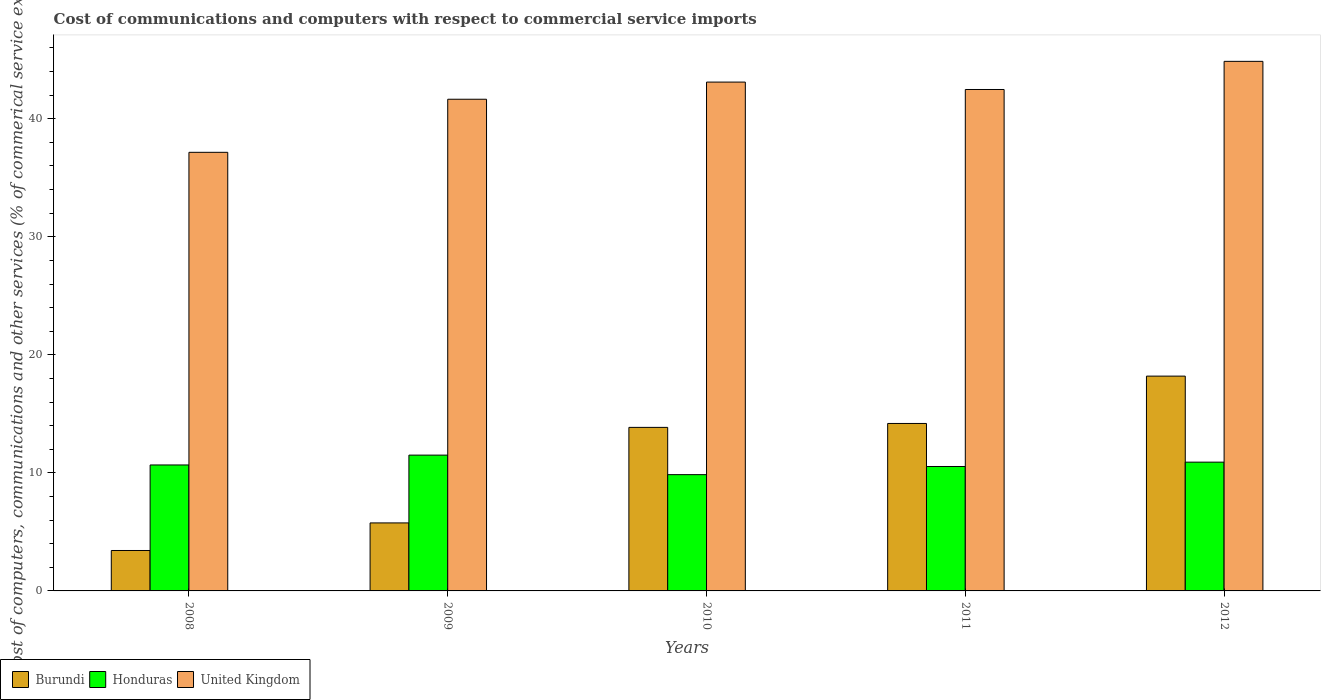How many groups of bars are there?
Provide a short and direct response. 5. Are the number of bars per tick equal to the number of legend labels?
Give a very brief answer. Yes. Are the number of bars on each tick of the X-axis equal?
Ensure brevity in your answer.  Yes. How many bars are there on the 1st tick from the left?
Offer a very short reply. 3. What is the cost of communications and computers in Honduras in 2010?
Keep it short and to the point. 9.85. Across all years, what is the maximum cost of communications and computers in Burundi?
Provide a succinct answer. 18.2. Across all years, what is the minimum cost of communications and computers in Burundi?
Provide a short and direct response. 3.43. In which year was the cost of communications and computers in United Kingdom maximum?
Keep it short and to the point. 2012. What is the total cost of communications and computers in Burundi in the graph?
Make the answer very short. 55.42. What is the difference between the cost of communications and computers in Burundi in 2008 and that in 2009?
Keep it short and to the point. -2.34. What is the difference between the cost of communications and computers in Burundi in 2011 and the cost of communications and computers in Honduras in 2012?
Your answer should be very brief. 3.28. What is the average cost of communications and computers in United Kingdom per year?
Provide a short and direct response. 41.85. In the year 2008, what is the difference between the cost of communications and computers in United Kingdom and cost of communications and computers in Honduras?
Keep it short and to the point. 26.49. In how many years, is the cost of communications and computers in United Kingdom greater than 10 %?
Keep it short and to the point. 5. What is the ratio of the cost of communications and computers in Honduras in 2009 to that in 2010?
Your response must be concise. 1.17. What is the difference between the highest and the second highest cost of communications and computers in Honduras?
Make the answer very short. 0.6. What is the difference between the highest and the lowest cost of communications and computers in Honduras?
Offer a very short reply. 1.65. Is the sum of the cost of communications and computers in Burundi in 2008 and 2009 greater than the maximum cost of communications and computers in United Kingdom across all years?
Your answer should be very brief. No. What does the 2nd bar from the left in 2010 represents?
Give a very brief answer. Honduras. What does the 1st bar from the right in 2012 represents?
Provide a short and direct response. United Kingdom. Is it the case that in every year, the sum of the cost of communications and computers in United Kingdom and cost of communications and computers in Burundi is greater than the cost of communications and computers in Honduras?
Your response must be concise. Yes. How many bars are there?
Keep it short and to the point. 15. Are all the bars in the graph horizontal?
Provide a succinct answer. No. How many years are there in the graph?
Offer a terse response. 5. What is the difference between two consecutive major ticks on the Y-axis?
Offer a terse response. 10. Are the values on the major ticks of Y-axis written in scientific E-notation?
Your answer should be very brief. No. Does the graph contain grids?
Ensure brevity in your answer.  No. Where does the legend appear in the graph?
Offer a terse response. Bottom left. What is the title of the graph?
Make the answer very short. Cost of communications and computers with respect to commercial service imports. What is the label or title of the X-axis?
Offer a terse response. Years. What is the label or title of the Y-axis?
Ensure brevity in your answer.  Cost of computers, communications and other services (% of commerical service exports). What is the Cost of computers, communications and other services (% of commerical service exports) of Burundi in 2008?
Your answer should be very brief. 3.43. What is the Cost of computers, communications and other services (% of commerical service exports) in Honduras in 2008?
Offer a very short reply. 10.67. What is the Cost of computers, communications and other services (% of commerical service exports) in United Kingdom in 2008?
Your answer should be very brief. 37.16. What is the Cost of computers, communications and other services (% of commerical service exports) of Burundi in 2009?
Provide a short and direct response. 5.76. What is the Cost of computers, communications and other services (% of commerical service exports) of Honduras in 2009?
Offer a very short reply. 11.5. What is the Cost of computers, communications and other services (% of commerical service exports) in United Kingdom in 2009?
Provide a succinct answer. 41.65. What is the Cost of computers, communications and other services (% of commerical service exports) of Burundi in 2010?
Your answer should be compact. 13.85. What is the Cost of computers, communications and other services (% of commerical service exports) of Honduras in 2010?
Your response must be concise. 9.85. What is the Cost of computers, communications and other services (% of commerical service exports) of United Kingdom in 2010?
Your response must be concise. 43.11. What is the Cost of computers, communications and other services (% of commerical service exports) of Burundi in 2011?
Ensure brevity in your answer.  14.19. What is the Cost of computers, communications and other services (% of commerical service exports) of Honduras in 2011?
Keep it short and to the point. 10.54. What is the Cost of computers, communications and other services (% of commerical service exports) of United Kingdom in 2011?
Provide a short and direct response. 42.48. What is the Cost of computers, communications and other services (% of commerical service exports) in Burundi in 2012?
Your answer should be compact. 18.2. What is the Cost of computers, communications and other services (% of commerical service exports) of Honduras in 2012?
Your answer should be very brief. 10.91. What is the Cost of computers, communications and other services (% of commerical service exports) in United Kingdom in 2012?
Offer a terse response. 44.86. Across all years, what is the maximum Cost of computers, communications and other services (% of commerical service exports) of Burundi?
Offer a terse response. 18.2. Across all years, what is the maximum Cost of computers, communications and other services (% of commerical service exports) in Honduras?
Make the answer very short. 11.5. Across all years, what is the maximum Cost of computers, communications and other services (% of commerical service exports) in United Kingdom?
Offer a terse response. 44.86. Across all years, what is the minimum Cost of computers, communications and other services (% of commerical service exports) in Burundi?
Your response must be concise. 3.43. Across all years, what is the minimum Cost of computers, communications and other services (% of commerical service exports) of Honduras?
Offer a very short reply. 9.85. Across all years, what is the minimum Cost of computers, communications and other services (% of commerical service exports) of United Kingdom?
Give a very brief answer. 37.16. What is the total Cost of computers, communications and other services (% of commerical service exports) of Burundi in the graph?
Keep it short and to the point. 55.42. What is the total Cost of computers, communications and other services (% of commerical service exports) in Honduras in the graph?
Your answer should be compact. 53.47. What is the total Cost of computers, communications and other services (% of commerical service exports) in United Kingdom in the graph?
Your answer should be very brief. 209.26. What is the difference between the Cost of computers, communications and other services (% of commerical service exports) of Burundi in 2008 and that in 2009?
Your response must be concise. -2.34. What is the difference between the Cost of computers, communications and other services (% of commerical service exports) of Honduras in 2008 and that in 2009?
Provide a short and direct response. -0.83. What is the difference between the Cost of computers, communications and other services (% of commerical service exports) of United Kingdom in 2008 and that in 2009?
Your response must be concise. -4.5. What is the difference between the Cost of computers, communications and other services (% of commerical service exports) of Burundi in 2008 and that in 2010?
Provide a short and direct response. -10.43. What is the difference between the Cost of computers, communications and other services (% of commerical service exports) of Honduras in 2008 and that in 2010?
Provide a short and direct response. 0.82. What is the difference between the Cost of computers, communications and other services (% of commerical service exports) in United Kingdom in 2008 and that in 2010?
Make the answer very short. -5.95. What is the difference between the Cost of computers, communications and other services (% of commerical service exports) of Burundi in 2008 and that in 2011?
Give a very brief answer. -10.76. What is the difference between the Cost of computers, communications and other services (% of commerical service exports) in Honduras in 2008 and that in 2011?
Offer a very short reply. 0.13. What is the difference between the Cost of computers, communications and other services (% of commerical service exports) of United Kingdom in 2008 and that in 2011?
Your answer should be very brief. -5.32. What is the difference between the Cost of computers, communications and other services (% of commerical service exports) in Burundi in 2008 and that in 2012?
Give a very brief answer. -14.77. What is the difference between the Cost of computers, communications and other services (% of commerical service exports) of Honduras in 2008 and that in 2012?
Offer a very short reply. -0.24. What is the difference between the Cost of computers, communications and other services (% of commerical service exports) in United Kingdom in 2008 and that in 2012?
Provide a short and direct response. -7.71. What is the difference between the Cost of computers, communications and other services (% of commerical service exports) of Burundi in 2009 and that in 2010?
Give a very brief answer. -8.09. What is the difference between the Cost of computers, communications and other services (% of commerical service exports) of Honduras in 2009 and that in 2010?
Provide a short and direct response. 1.65. What is the difference between the Cost of computers, communications and other services (% of commerical service exports) in United Kingdom in 2009 and that in 2010?
Provide a succinct answer. -1.45. What is the difference between the Cost of computers, communications and other services (% of commerical service exports) of Burundi in 2009 and that in 2011?
Keep it short and to the point. -8.43. What is the difference between the Cost of computers, communications and other services (% of commerical service exports) in Honduras in 2009 and that in 2011?
Keep it short and to the point. 0.96. What is the difference between the Cost of computers, communications and other services (% of commerical service exports) of United Kingdom in 2009 and that in 2011?
Provide a succinct answer. -0.83. What is the difference between the Cost of computers, communications and other services (% of commerical service exports) in Burundi in 2009 and that in 2012?
Your response must be concise. -12.44. What is the difference between the Cost of computers, communications and other services (% of commerical service exports) in Honduras in 2009 and that in 2012?
Keep it short and to the point. 0.6. What is the difference between the Cost of computers, communications and other services (% of commerical service exports) of United Kingdom in 2009 and that in 2012?
Offer a terse response. -3.21. What is the difference between the Cost of computers, communications and other services (% of commerical service exports) in Burundi in 2010 and that in 2011?
Offer a terse response. -0.33. What is the difference between the Cost of computers, communications and other services (% of commerical service exports) in Honduras in 2010 and that in 2011?
Make the answer very short. -0.69. What is the difference between the Cost of computers, communications and other services (% of commerical service exports) in United Kingdom in 2010 and that in 2011?
Offer a very short reply. 0.63. What is the difference between the Cost of computers, communications and other services (% of commerical service exports) of Burundi in 2010 and that in 2012?
Give a very brief answer. -4.34. What is the difference between the Cost of computers, communications and other services (% of commerical service exports) of Honduras in 2010 and that in 2012?
Give a very brief answer. -1.06. What is the difference between the Cost of computers, communications and other services (% of commerical service exports) of United Kingdom in 2010 and that in 2012?
Offer a very short reply. -1.76. What is the difference between the Cost of computers, communications and other services (% of commerical service exports) of Burundi in 2011 and that in 2012?
Your answer should be very brief. -4.01. What is the difference between the Cost of computers, communications and other services (% of commerical service exports) of Honduras in 2011 and that in 2012?
Ensure brevity in your answer.  -0.37. What is the difference between the Cost of computers, communications and other services (% of commerical service exports) in United Kingdom in 2011 and that in 2012?
Your response must be concise. -2.38. What is the difference between the Cost of computers, communications and other services (% of commerical service exports) in Burundi in 2008 and the Cost of computers, communications and other services (% of commerical service exports) in Honduras in 2009?
Give a very brief answer. -8.08. What is the difference between the Cost of computers, communications and other services (% of commerical service exports) of Burundi in 2008 and the Cost of computers, communications and other services (% of commerical service exports) of United Kingdom in 2009?
Ensure brevity in your answer.  -38.23. What is the difference between the Cost of computers, communications and other services (% of commerical service exports) in Honduras in 2008 and the Cost of computers, communications and other services (% of commerical service exports) in United Kingdom in 2009?
Your response must be concise. -30.98. What is the difference between the Cost of computers, communications and other services (% of commerical service exports) in Burundi in 2008 and the Cost of computers, communications and other services (% of commerical service exports) in Honduras in 2010?
Provide a short and direct response. -6.43. What is the difference between the Cost of computers, communications and other services (% of commerical service exports) of Burundi in 2008 and the Cost of computers, communications and other services (% of commerical service exports) of United Kingdom in 2010?
Offer a very short reply. -39.68. What is the difference between the Cost of computers, communications and other services (% of commerical service exports) in Honduras in 2008 and the Cost of computers, communications and other services (% of commerical service exports) in United Kingdom in 2010?
Your answer should be compact. -32.44. What is the difference between the Cost of computers, communications and other services (% of commerical service exports) of Burundi in 2008 and the Cost of computers, communications and other services (% of commerical service exports) of Honduras in 2011?
Give a very brief answer. -7.11. What is the difference between the Cost of computers, communications and other services (% of commerical service exports) in Burundi in 2008 and the Cost of computers, communications and other services (% of commerical service exports) in United Kingdom in 2011?
Your answer should be very brief. -39.05. What is the difference between the Cost of computers, communications and other services (% of commerical service exports) of Honduras in 2008 and the Cost of computers, communications and other services (% of commerical service exports) of United Kingdom in 2011?
Provide a succinct answer. -31.81. What is the difference between the Cost of computers, communications and other services (% of commerical service exports) of Burundi in 2008 and the Cost of computers, communications and other services (% of commerical service exports) of Honduras in 2012?
Give a very brief answer. -7.48. What is the difference between the Cost of computers, communications and other services (% of commerical service exports) in Burundi in 2008 and the Cost of computers, communications and other services (% of commerical service exports) in United Kingdom in 2012?
Ensure brevity in your answer.  -41.44. What is the difference between the Cost of computers, communications and other services (% of commerical service exports) in Honduras in 2008 and the Cost of computers, communications and other services (% of commerical service exports) in United Kingdom in 2012?
Provide a short and direct response. -34.19. What is the difference between the Cost of computers, communications and other services (% of commerical service exports) in Burundi in 2009 and the Cost of computers, communications and other services (% of commerical service exports) in Honduras in 2010?
Offer a terse response. -4.09. What is the difference between the Cost of computers, communications and other services (% of commerical service exports) of Burundi in 2009 and the Cost of computers, communications and other services (% of commerical service exports) of United Kingdom in 2010?
Make the answer very short. -37.35. What is the difference between the Cost of computers, communications and other services (% of commerical service exports) in Honduras in 2009 and the Cost of computers, communications and other services (% of commerical service exports) in United Kingdom in 2010?
Offer a terse response. -31.6. What is the difference between the Cost of computers, communications and other services (% of commerical service exports) of Burundi in 2009 and the Cost of computers, communications and other services (% of commerical service exports) of Honduras in 2011?
Ensure brevity in your answer.  -4.78. What is the difference between the Cost of computers, communications and other services (% of commerical service exports) of Burundi in 2009 and the Cost of computers, communications and other services (% of commerical service exports) of United Kingdom in 2011?
Offer a terse response. -36.72. What is the difference between the Cost of computers, communications and other services (% of commerical service exports) of Honduras in 2009 and the Cost of computers, communications and other services (% of commerical service exports) of United Kingdom in 2011?
Your answer should be very brief. -30.97. What is the difference between the Cost of computers, communications and other services (% of commerical service exports) of Burundi in 2009 and the Cost of computers, communications and other services (% of commerical service exports) of Honduras in 2012?
Give a very brief answer. -5.15. What is the difference between the Cost of computers, communications and other services (% of commerical service exports) in Burundi in 2009 and the Cost of computers, communications and other services (% of commerical service exports) in United Kingdom in 2012?
Your answer should be compact. -39.1. What is the difference between the Cost of computers, communications and other services (% of commerical service exports) of Honduras in 2009 and the Cost of computers, communications and other services (% of commerical service exports) of United Kingdom in 2012?
Give a very brief answer. -33.36. What is the difference between the Cost of computers, communications and other services (% of commerical service exports) of Burundi in 2010 and the Cost of computers, communications and other services (% of commerical service exports) of Honduras in 2011?
Give a very brief answer. 3.31. What is the difference between the Cost of computers, communications and other services (% of commerical service exports) in Burundi in 2010 and the Cost of computers, communications and other services (% of commerical service exports) in United Kingdom in 2011?
Offer a very short reply. -28.62. What is the difference between the Cost of computers, communications and other services (% of commerical service exports) in Honduras in 2010 and the Cost of computers, communications and other services (% of commerical service exports) in United Kingdom in 2011?
Make the answer very short. -32.63. What is the difference between the Cost of computers, communications and other services (% of commerical service exports) in Burundi in 2010 and the Cost of computers, communications and other services (% of commerical service exports) in Honduras in 2012?
Make the answer very short. 2.95. What is the difference between the Cost of computers, communications and other services (% of commerical service exports) of Burundi in 2010 and the Cost of computers, communications and other services (% of commerical service exports) of United Kingdom in 2012?
Provide a short and direct response. -31.01. What is the difference between the Cost of computers, communications and other services (% of commerical service exports) in Honduras in 2010 and the Cost of computers, communications and other services (% of commerical service exports) in United Kingdom in 2012?
Provide a succinct answer. -35.01. What is the difference between the Cost of computers, communications and other services (% of commerical service exports) of Burundi in 2011 and the Cost of computers, communications and other services (% of commerical service exports) of Honduras in 2012?
Keep it short and to the point. 3.28. What is the difference between the Cost of computers, communications and other services (% of commerical service exports) of Burundi in 2011 and the Cost of computers, communications and other services (% of commerical service exports) of United Kingdom in 2012?
Offer a terse response. -30.68. What is the difference between the Cost of computers, communications and other services (% of commerical service exports) of Honduras in 2011 and the Cost of computers, communications and other services (% of commerical service exports) of United Kingdom in 2012?
Provide a short and direct response. -34.32. What is the average Cost of computers, communications and other services (% of commerical service exports) of Burundi per year?
Provide a short and direct response. 11.08. What is the average Cost of computers, communications and other services (% of commerical service exports) in Honduras per year?
Offer a terse response. 10.69. What is the average Cost of computers, communications and other services (% of commerical service exports) in United Kingdom per year?
Your answer should be very brief. 41.85. In the year 2008, what is the difference between the Cost of computers, communications and other services (% of commerical service exports) of Burundi and Cost of computers, communications and other services (% of commerical service exports) of Honduras?
Give a very brief answer. -7.24. In the year 2008, what is the difference between the Cost of computers, communications and other services (% of commerical service exports) of Burundi and Cost of computers, communications and other services (% of commerical service exports) of United Kingdom?
Your response must be concise. -33.73. In the year 2008, what is the difference between the Cost of computers, communications and other services (% of commerical service exports) in Honduras and Cost of computers, communications and other services (% of commerical service exports) in United Kingdom?
Your response must be concise. -26.49. In the year 2009, what is the difference between the Cost of computers, communications and other services (% of commerical service exports) in Burundi and Cost of computers, communications and other services (% of commerical service exports) in Honduras?
Provide a succinct answer. -5.74. In the year 2009, what is the difference between the Cost of computers, communications and other services (% of commerical service exports) of Burundi and Cost of computers, communications and other services (% of commerical service exports) of United Kingdom?
Provide a succinct answer. -35.89. In the year 2009, what is the difference between the Cost of computers, communications and other services (% of commerical service exports) in Honduras and Cost of computers, communications and other services (% of commerical service exports) in United Kingdom?
Your answer should be very brief. -30.15. In the year 2010, what is the difference between the Cost of computers, communications and other services (% of commerical service exports) in Burundi and Cost of computers, communications and other services (% of commerical service exports) in Honduras?
Ensure brevity in your answer.  4. In the year 2010, what is the difference between the Cost of computers, communications and other services (% of commerical service exports) in Burundi and Cost of computers, communications and other services (% of commerical service exports) in United Kingdom?
Keep it short and to the point. -29.25. In the year 2010, what is the difference between the Cost of computers, communications and other services (% of commerical service exports) in Honduras and Cost of computers, communications and other services (% of commerical service exports) in United Kingdom?
Your response must be concise. -33.26. In the year 2011, what is the difference between the Cost of computers, communications and other services (% of commerical service exports) of Burundi and Cost of computers, communications and other services (% of commerical service exports) of Honduras?
Make the answer very short. 3.65. In the year 2011, what is the difference between the Cost of computers, communications and other services (% of commerical service exports) in Burundi and Cost of computers, communications and other services (% of commerical service exports) in United Kingdom?
Your response must be concise. -28.29. In the year 2011, what is the difference between the Cost of computers, communications and other services (% of commerical service exports) in Honduras and Cost of computers, communications and other services (% of commerical service exports) in United Kingdom?
Provide a succinct answer. -31.94. In the year 2012, what is the difference between the Cost of computers, communications and other services (% of commerical service exports) in Burundi and Cost of computers, communications and other services (% of commerical service exports) in Honduras?
Provide a short and direct response. 7.29. In the year 2012, what is the difference between the Cost of computers, communications and other services (% of commerical service exports) of Burundi and Cost of computers, communications and other services (% of commerical service exports) of United Kingdom?
Your response must be concise. -26.66. In the year 2012, what is the difference between the Cost of computers, communications and other services (% of commerical service exports) in Honduras and Cost of computers, communications and other services (% of commerical service exports) in United Kingdom?
Offer a very short reply. -33.95. What is the ratio of the Cost of computers, communications and other services (% of commerical service exports) in Burundi in 2008 to that in 2009?
Provide a short and direct response. 0.59. What is the ratio of the Cost of computers, communications and other services (% of commerical service exports) of Honduras in 2008 to that in 2009?
Your answer should be compact. 0.93. What is the ratio of the Cost of computers, communications and other services (% of commerical service exports) of United Kingdom in 2008 to that in 2009?
Make the answer very short. 0.89. What is the ratio of the Cost of computers, communications and other services (% of commerical service exports) of Burundi in 2008 to that in 2010?
Ensure brevity in your answer.  0.25. What is the ratio of the Cost of computers, communications and other services (% of commerical service exports) in Honduras in 2008 to that in 2010?
Your answer should be very brief. 1.08. What is the ratio of the Cost of computers, communications and other services (% of commerical service exports) of United Kingdom in 2008 to that in 2010?
Keep it short and to the point. 0.86. What is the ratio of the Cost of computers, communications and other services (% of commerical service exports) in Burundi in 2008 to that in 2011?
Give a very brief answer. 0.24. What is the ratio of the Cost of computers, communications and other services (% of commerical service exports) in Honduras in 2008 to that in 2011?
Offer a terse response. 1.01. What is the ratio of the Cost of computers, communications and other services (% of commerical service exports) of United Kingdom in 2008 to that in 2011?
Ensure brevity in your answer.  0.87. What is the ratio of the Cost of computers, communications and other services (% of commerical service exports) of Burundi in 2008 to that in 2012?
Make the answer very short. 0.19. What is the ratio of the Cost of computers, communications and other services (% of commerical service exports) of Honduras in 2008 to that in 2012?
Your answer should be compact. 0.98. What is the ratio of the Cost of computers, communications and other services (% of commerical service exports) in United Kingdom in 2008 to that in 2012?
Keep it short and to the point. 0.83. What is the ratio of the Cost of computers, communications and other services (% of commerical service exports) of Burundi in 2009 to that in 2010?
Provide a succinct answer. 0.42. What is the ratio of the Cost of computers, communications and other services (% of commerical service exports) in Honduras in 2009 to that in 2010?
Provide a succinct answer. 1.17. What is the ratio of the Cost of computers, communications and other services (% of commerical service exports) of United Kingdom in 2009 to that in 2010?
Make the answer very short. 0.97. What is the ratio of the Cost of computers, communications and other services (% of commerical service exports) in Burundi in 2009 to that in 2011?
Your answer should be very brief. 0.41. What is the ratio of the Cost of computers, communications and other services (% of commerical service exports) in Honduras in 2009 to that in 2011?
Your answer should be compact. 1.09. What is the ratio of the Cost of computers, communications and other services (% of commerical service exports) of United Kingdom in 2009 to that in 2011?
Your response must be concise. 0.98. What is the ratio of the Cost of computers, communications and other services (% of commerical service exports) in Burundi in 2009 to that in 2012?
Provide a succinct answer. 0.32. What is the ratio of the Cost of computers, communications and other services (% of commerical service exports) of Honduras in 2009 to that in 2012?
Provide a short and direct response. 1.05. What is the ratio of the Cost of computers, communications and other services (% of commerical service exports) in United Kingdom in 2009 to that in 2012?
Provide a succinct answer. 0.93. What is the ratio of the Cost of computers, communications and other services (% of commerical service exports) in Burundi in 2010 to that in 2011?
Give a very brief answer. 0.98. What is the ratio of the Cost of computers, communications and other services (% of commerical service exports) of Honduras in 2010 to that in 2011?
Keep it short and to the point. 0.93. What is the ratio of the Cost of computers, communications and other services (% of commerical service exports) in United Kingdom in 2010 to that in 2011?
Provide a short and direct response. 1.01. What is the ratio of the Cost of computers, communications and other services (% of commerical service exports) of Burundi in 2010 to that in 2012?
Make the answer very short. 0.76. What is the ratio of the Cost of computers, communications and other services (% of commerical service exports) of Honduras in 2010 to that in 2012?
Make the answer very short. 0.9. What is the ratio of the Cost of computers, communications and other services (% of commerical service exports) in United Kingdom in 2010 to that in 2012?
Provide a succinct answer. 0.96. What is the ratio of the Cost of computers, communications and other services (% of commerical service exports) in Burundi in 2011 to that in 2012?
Give a very brief answer. 0.78. What is the ratio of the Cost of computers, communications and other services (% of commerical service exports) of Honduras in 2011 to that in 2012?
Provide a short and direct response. 0.97. What is the ratio of the Cost of computers, communications and other services (% of commerical service exports) in United Kingdom in 2011 to that in 2012?
Your answer should be compact. 0.95. What is the difference between the highest and the second highest Cost of computers, communications and other services (% of commerical service exports) in Burundi?
Ensure brevity in your answer.  4.01. What is the difference between the highest and the second highest Cost of computers, communications and other services (% of commerical service exports) in Honduras?
Provide a succinct answer. 0.6. What is the difference between the highest and the second highest Cost of computers, communications and other services (% of commerical service exports) of United Kingdom?
Provide a short and direct response. 1.76. What is the difference between the highest and the lowest Cost of computers, communications and other services (% of commerical service exports) of Burundi?
Your answer should be very brief. 14.77. What is the difference between the highest and the lowest Cost of computers, communications and other services (% of commerical service exports) in Honduras?
Give a very brief answer. 1.65. What is the difference between the highest and the lowest Cost of computers, communications and other services (% of commerical service exports) of United Kingdom?
Offer a very short reply. 7.71. 